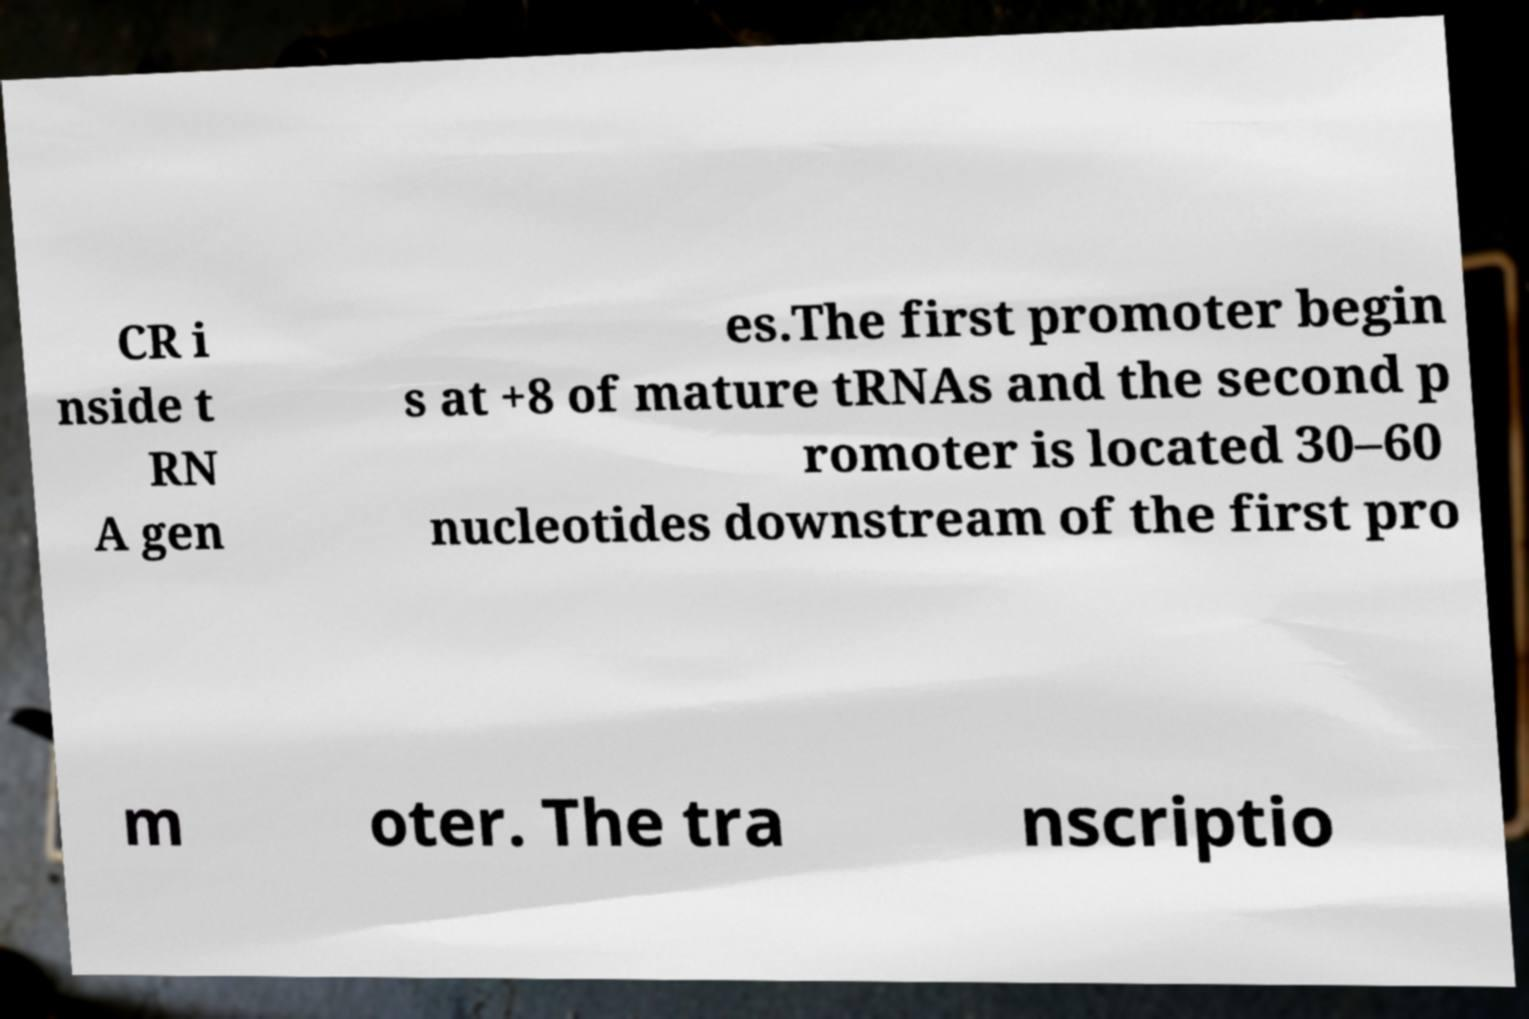Can you accurately transcribe the text from the provided image for me? CR i nside t RN A gen es.The first promoter begin s at +8 of mature tRNAs and the second p romoter is located 30–60 nucleotides downstream of the first pro m oter. The tra nscriptio 